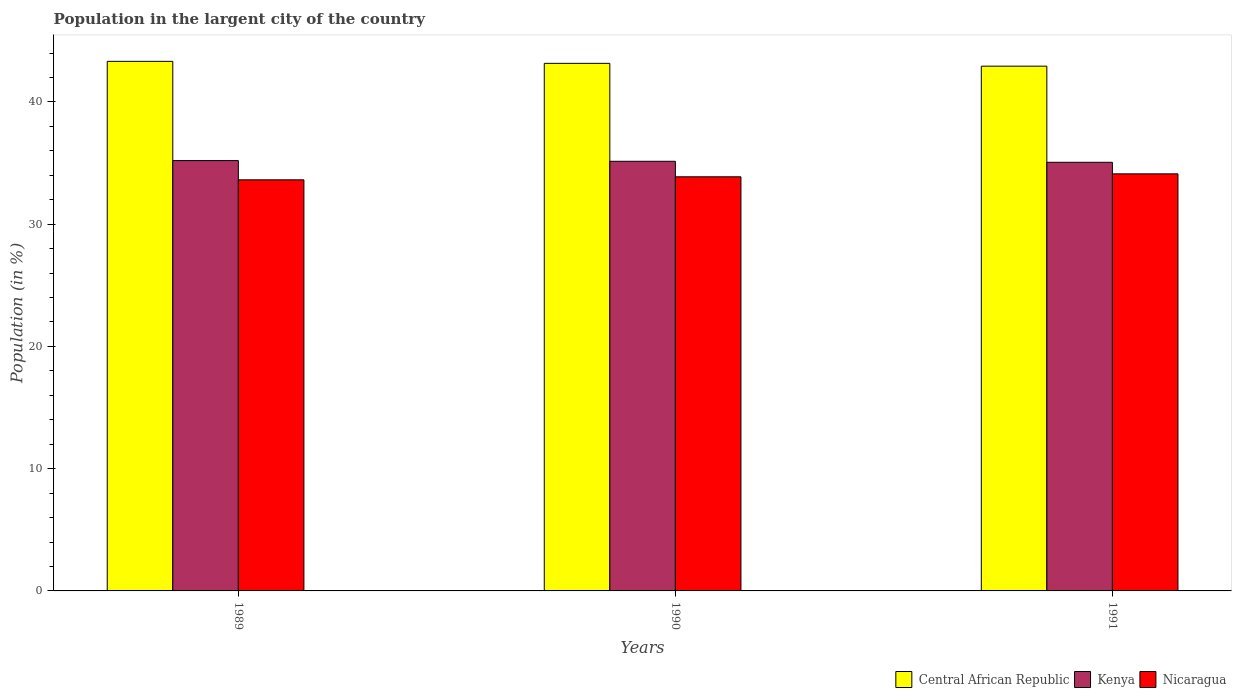Are the number of bars per tick equal to the number of legend labels?
Make the answer very short. Yes. Are the number of bars on each tick of the X-axis equal?
Your response must be concise. Yes. How many bars are there on the 3rd tick from the right?
Your answer should be very brief. 3. What is the percentage of population in the largent city in Nicaragua in 1990?
Your response must be concise. 33.87. Across all years, what is the maximum percentage of population in the largent city in Nicaragua?
Give a very brief answer. 34.12. Across all years, what is the minimum percentage of population in the largent city in Nicaragua?
Make the answer very short. 33.63. In which year was the percentage of population in the largent city in Nicaragua maximum?
Ensure brevity in your answer.  1991. In which year was the percentage of population in the largent city in Nicaragua minimum?
Offer a very short reply. 1989. What is the total percentage of population in the largent city in Kenya in the graph?
Provide a succinct answer. 105.4. What is the difference between the percentage of population in the largent city in Nicaragua in 1989 and that in 1991?
Your response must be concise. -0.49. What is the difference between the percentage of population in the largent city in Central African Republic in 1989 and the percentage of population in the largent city in Nicaragua in 1991?
Offer a very short reply. 9.2. What is the average percentage of population in the largent city in Central African Republic per year?
Provide a succinct answer. 43.13. In the year 1989, what is the difference between the percentage of population in the largent city in Central African Republic and percentage of population in the largent city in Kenya?
Your answer should be very brief. 8.12. In how many years, is the percentage of population in the largent city in Central African Republic greater than 34 %?
Give a very brief answer. 3. What is the ratio of the percentage of population in the largent city in Central African Republic in 1989 to that in 1990?
Make the answer very short. 1. What is the difference between the highest and the second highest percentage of population in the largent city in Central African Republic?
Your response must be concise. 0.16. What is the difference between the highest and the lowest percentage of population in the largent city in Kenya?
Your answer should be compact. 0.14. In how many years, is the percentage of population in the largent city in Kenya greater than the average percentage of population in the largent city in Kenya taken over all years?
Offer a very short reply. 2. What does the 3rd bar from the left in 1991 represents?
Provide a succinct answer. Nicaragua. What does the 2nd bar from the right in 1991 represents?
Make the answer very short. Kenya. Is it the case that in every year, the sum of the percentage of population in the largent city in Kenya and percentage of population in the largent city in Central African Republic is greater than the percentage of population in the largent city in Nicaragua?
Your answer should be compact. Yes. Are all the bars in the graph horizontal?
Your response must be concise. No. How many years are there in the graph?
Provide a succinct answer. 3. What is the difference between two consecutive major ticks on the Y-axis?
Your response must be concise. 10. Does the graph contain any zero values?
Your response must be concise. No. Does the graph contain grids?
Keep it short and to the point. No. How are the legend labels stacked?
Your answer should be very brief. Horizontal. What is the title of the graph?
Your answer should be compact. Population in the largent city of the country. Does "Guatemala" appear as one of the legend labels in the graph?
Provide a succinct answer. No. What is the label or title of the Y-axis?
Make the answer very short. Population (in %). What is the Population (in %) of Central African Republic in 1989?
Your response must be concise. 43.32. What is the Population (in %) of Kenya in 1989?
Your answer should be very brief. 35.2. What is the Population (in %) in Nicaragua in 1989?
Provide a short and direct response. 33.63. What is the Population (in %) in Central African Republic in 1990?
Keep it short and to the point. 43.16. What is the Population (in %) of Kenya in 1990?
Make the answer very short. 35.14. What is the Population (in %) of Nicaragua in 1990?
Your response must be concise. 33.87. What is the Population (in %) of Central African Republic in 1991?
Provide a short and direct response. 42.93. What is the Population (in %) in Kenya in 1991?
Your response must be concise. 35.06. What is the Population (in %) in Nicaragua in 1991?
Keep it short and to the point. 34.12. Across all years, what is the maximum Population (in %) of Central African Republic?
Ensure brevity in your answer.  43.32. Across all years, what is the maximum Population (in %) in Kenya?
Your answer should be very brief. 35.2. Across all years, what is the maximum Population (in %) of Nicaragua?
Ensure brevity in your answer.  34.12. Across all years, what is the minimum Population (in %) of Central African Republic?
Make the answer very short. 42.93. Across all years, what is the minimum Population (in %) of Kenya?
Your response must be concise. 35.06. Across all years, what is the minimum Population (in %) in Nicaragua?
Offer a terse response. 33.63. What is the total Population (in %) of Central African Republic in the graph?
Provide a succinct answer. 129.4. What is the total Population (in %) in Kenya in the graph?
Your answer should be very brief. 105.4. What is the total Population (in %) of Nicaragua in the graph?
Your answer should be compact. 101.62. What is the difference between the Population (in %) of Central African Republic in 1989 and that in 1990?
Ensure brevity in your answer.  0.16. What is the difference between the Population (in %) of Kenya in 1989 and that in 1990?
Keep it short and to the point. 0.06. What is the difference between the Population (in %) of Nicaragua in 1989 and that in 1990?
Provide a succinct answer. -0.25. What is the difference between the Population (in %) of Central African Republic in 1989 and that in 1991?
Make the answer very short. 0.39. What is the difference between the Population (in %) of Kenya in 1989 and that in 1991?
Your answer should be very brief. 0.14. What is the difference between the Population (in %) of Nicaragua in 1989 and that in 1991?
Offer a terse response. -0.49. What is the difference between the Population (in %) in Central African Republic in 1990 and that in 1991?
Ensure brevity in your answer.  0.23. What is the difference between the Population (in %) in Kenya in 1990 and that in 1991?
Provide a short and direct response. 0.08. What is the difference between the Population (in %) in Nicaragua in 1990 and that in 1991?
Keep it short and to the point. -0.24. What is the difference between the Population (in %) of Central African Republic in 1989 and the Population (in %) of Kenya in 1990?
Your response must be concise. 8.17. What is the difference between the Population (in %) in Central African Republic in 1989 and the Population (in %) in Nicaragua in 1990?
Make the answer very short. 9.44. What is the difference between the Population (in %) of Kenya in 1989 and the Population (in %) of Nicaragua in 1990?
Provide a succinct answer. 1.33. What is the difference between the Population (in %) of Central African Republic in 1989 and the Population (in %) of Kenya in 1991?
Your answer should be compact. 8.26. What is the difference between the Population (in %) in Central African Republic in 1989 and the Population (in %) in Nicaragua in 1991?
Your response must be concise. 9.2. What is the difference between the Population (in %) in Kenya in 1989 and the Population (in %) in Nicaragua in 1991?
Offer a very short reply. 1.08. What is the difference between the Population (in %) in Central African Republic in 1990 and the Population (in %) in Kenya in 1991?
Make the answer very short. 8.1. What is the difference between the Population (in %) in Central African Republic in 1990 and the Population (in %) in Nicaragua in 1991?
Your response must be concise. 9.04. What is the difference between the Population (in %) in Kenya in 1990 and the Population (in %) in Nicaragua in 1991?
Offer a terse response. 1.03. What is the average Population (in %) in Central African Republic per year?
Offer a very short reply. 43.13. What is the average Population (in %) of Kenya per year?
Your answer should be very brief. 35.13. What is the average Population (in %) in Nicaragua per year?
Offer a terse response. 33.87. In the year 1989, what is the difference between the Population (in %) of Central African Republic and Population (in %) of Kenya?
Give a very brief answer. 8.12. In the year 1989, what is the difference between the Population (in %) of Central African Republic and Population (in %) of Nicaragua?
Offer a terse response. 9.69. In the year 1989, what is the difference between the Population (in %) of Kenya and Population (in %) of Nicaragua?
Offer a very short reply. 1.57. In the year 1990, what is the difference between the Population (in %) of Central African Republic and Population (in %) of Kenya?
Keep it short and to the point. 8.01. In the year 1990, what is the difference between the Population (in %) of Central African Republic and Population (in %) of Nicaragua?
Ensure brevity in your answer.  9.28. In the year 1990, what is the difference between the Population (in %) in Kenya and Population (in %) in Nicaragua?
Your response must be concise. 1.27. In the year 1991, what is the difference between the Population (in %) in Central African Republic and Population (in %) in Kenya?
Your answer should be compact. 7.87. In the year 1991, what is the difference between the Population (in %) of Central African Republic and Population (in %) of Nicaragua?
Your answer should be very brief. 8.81. In the year 1991, what is the difference between the Population (in %) of Kenya and Population (in %) of Nicaragua?
Provide a short and direct response. 0.94. What is the ratio of the Population (in %) in Central African Republic in 1989 to that in 1990?
Offer a very short reply. 1. What is the ratio of the Population (in %) of Kenya in 1989 to that in 1990?
Keep it short and to the point. 1. What is the ratio of the Population (in %) in Nicaragua in 1989 to that in 1990?
Offer a terse response. 0.99. What is the ratio of the Population (in %) of Central African Republic in 1989 to that in 1991?
Make the answer very short. 1.01. What is the ratio of the Population (in %) of Nicaragua in 1989 to that in 1991?
Your response must be concise. 0.99. What is the ratio of the Population (in %) in Central African Republic in 1990 to that in 1991?
Make the answer very short. 1.01. What is the difference between the highest and the second highest Population (in %) in Central African Republic?
Offer a terse response. 0.16. What is the difference between the highest and the second highest Population (in %) in Kenya?
Your answer should be very brief. 0.06. What is the difference between the highest and the second highest Population (in %) of Nicaragua?
Your answer should be compact. 0.24. What is the difference between the highest and the lowest Population (in %) in Central African Republic?
Keep it short and to the point. 0.39. What is the difference between the highest and the lowest Population (in %) of Kenya?
Your response must be concise. 0.14. What is the difference between the highest and the lowest Population (in %) of Nicaragua?
Provide a succinct answer. 0.49. 